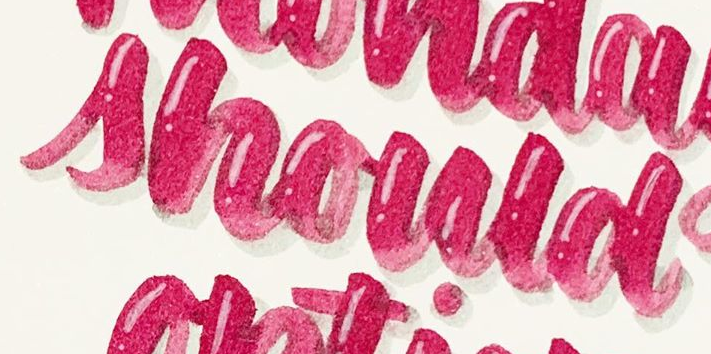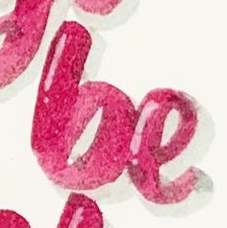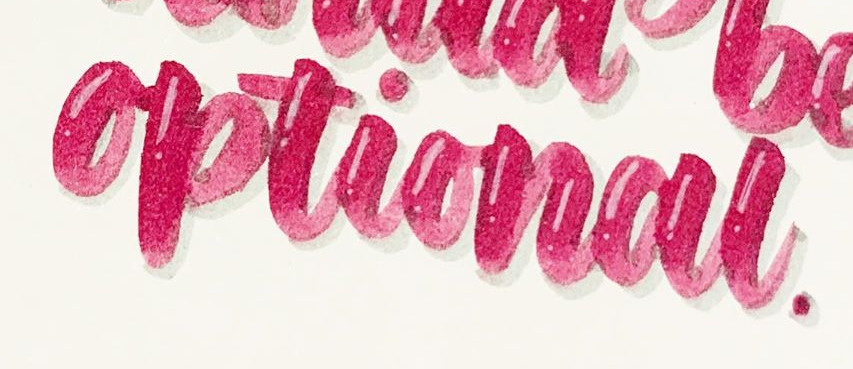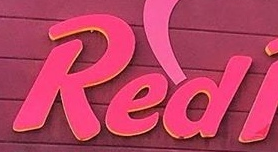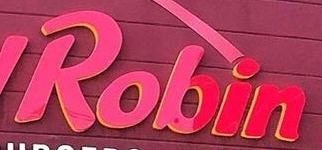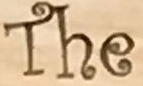Read the text from these images in sequence, separated by a semicolon. should; be; optional; Red; Robin; The 